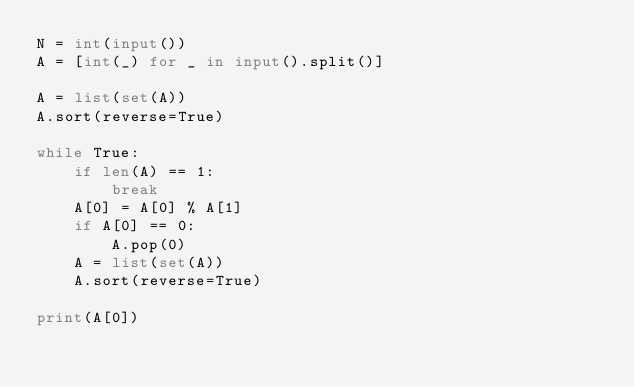<code> <loc_0><loc_0><loc_500><loc_500><_Python_>N = int(input())
A = [int(_) for _ in input().split()]

A = list(set(A))
A.sort(reverse=True)

while True:
    if len(A) == 1:
        break
    A[0] = A[0] % A[1]
    if A[0] == 0:
        A.pop(0)
    A = list(set(A))
    A.sort(reverse=True)

print(A[0])
</code> 